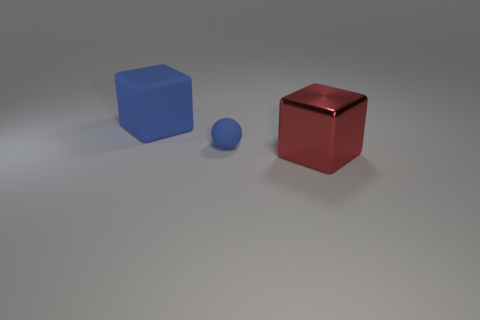There is another large object that is the same shape as the red metal object; what material is it?
Provide a short and direct response. Rubber. Is there any other thing that is the same size as the matte sphere?
Ensure brevity in your answer.  No. There is a cube that is behind the small blue rubber object; is it the same color as the block that is on the right side of the small blue rubber ball?
Offer a very short reply. No. There is a small object; what shape is it?
Keep it short and to the point. Sphere. Are there more matte objects to the right of the large rubber object than small blue metal blocks?
Your response must be concise. Yes. There is a large object that is left of the small sphere; what shape is it?
Make the answer very short. Cube. How many other things are the same shape as the red object?
Your response must be concise. 1. Are the blue thing in front of the blue cube and the big blue object made of the same material?
Keep it short and to the point. Yes. Is the number of blue matte cubes right of the matte block the same as the number of blue matte cubes that are on the right side of the tiny rubber sphere?
Give a very brief answer. Yes. What is the size of the blue thing that is in front of the matte cube?
Your response must be concise. Small. 